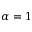<formula> <loc_0><loc_0><loc_500><loc_500>\alpha = 1</formula> 